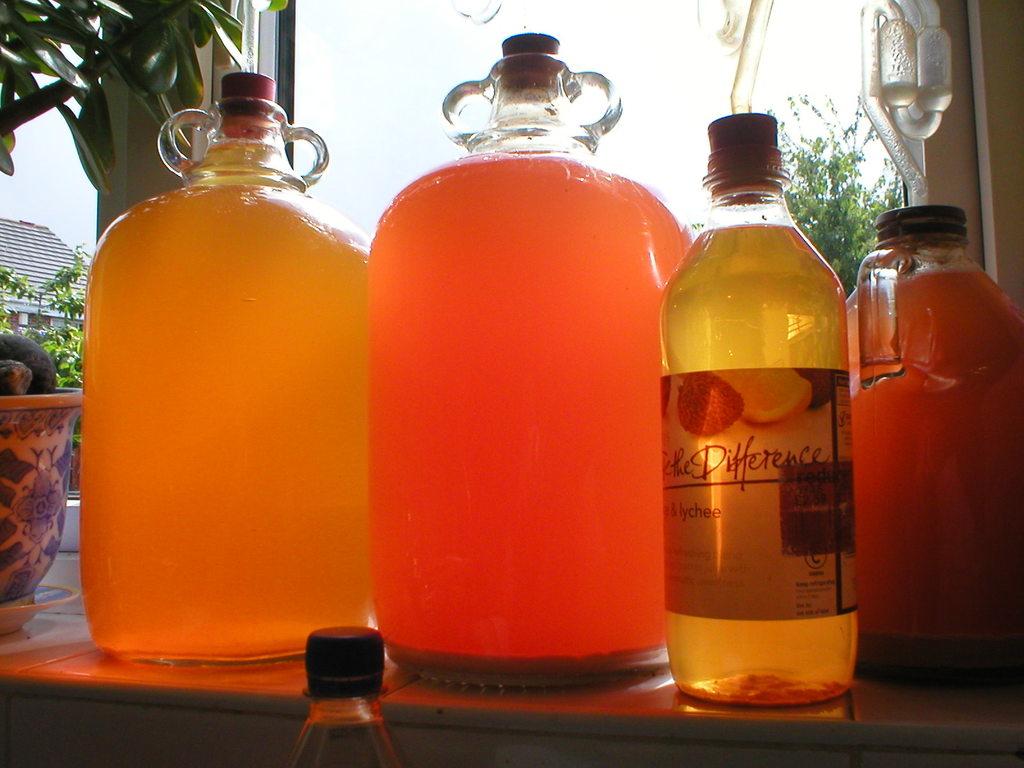What are the last two words of the brand on the bottle?
Ensure brevity in your answer.  The difference. 